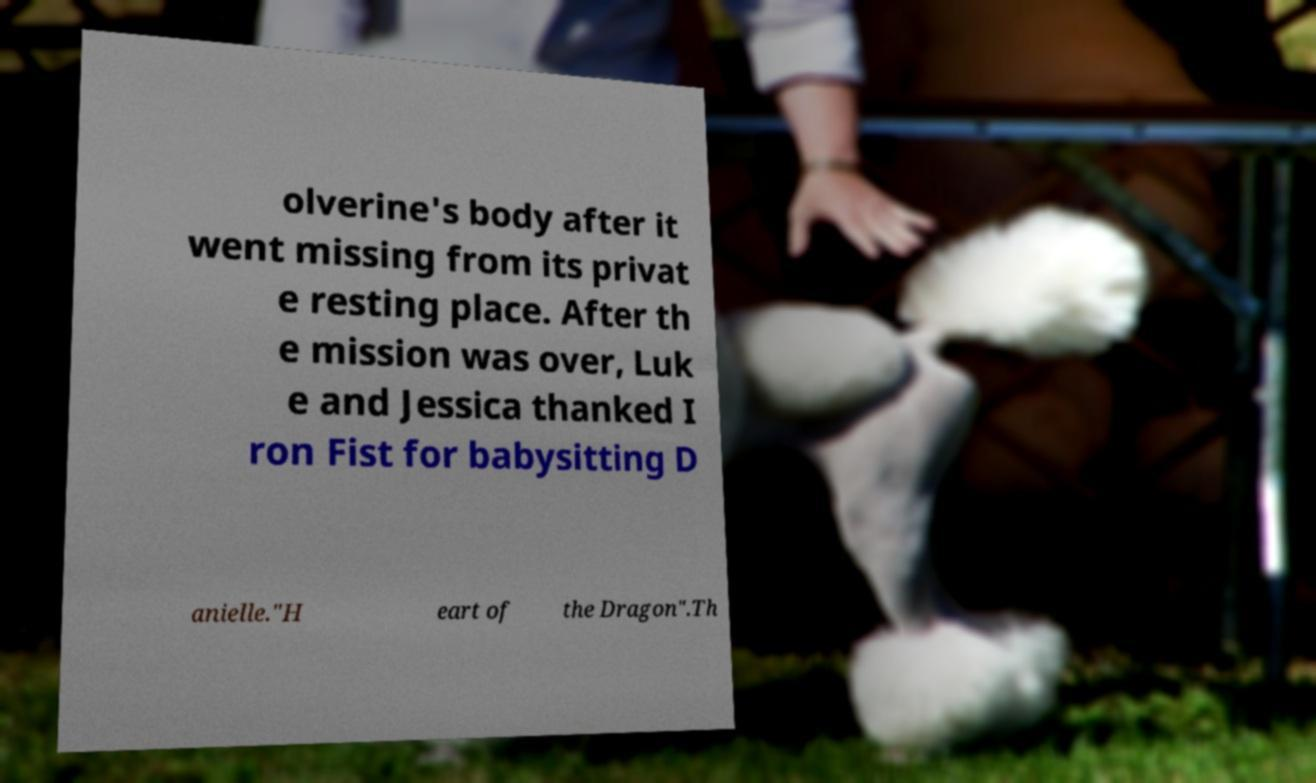I need the written content from this picture converted into text. Can you do that? olverine's body after it went missing from its privat e resting place. After th e mission was over, Luk e and Jessica thanked I ron Fist for babysitting D anielle."H eart of the Dragon".Th 